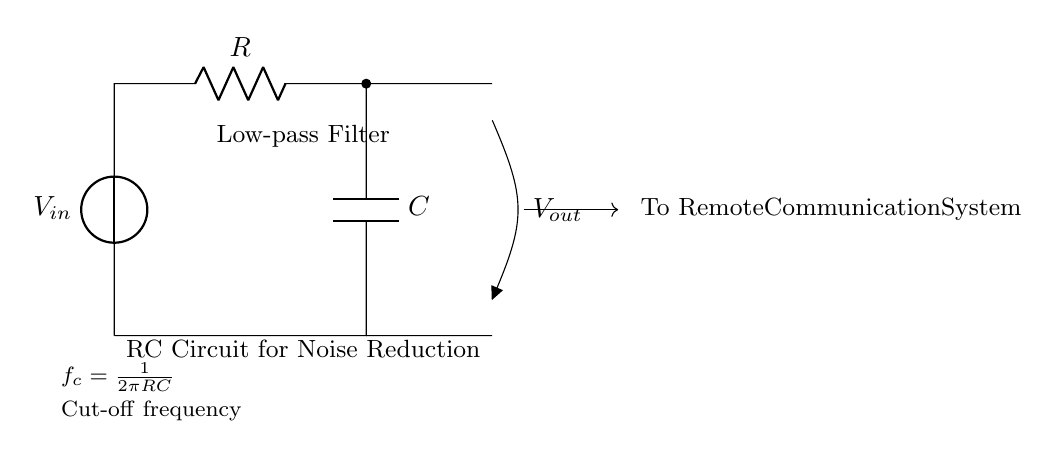What is the input voltage source labeled as? The input voltage source is labeled as V_in, meaning it is the voltage supplied to the circuit.
Answer: V_in What component is used for filtering in this circuit? The filtering component is the capacitor labeled as C, which works alongside the resistor to create the low-pass filter effect.
Answer: C What is the cut-off frequency formula shown in the diagram? The cut-off frequency formula is given as f_c = 1/(2πRC), indicating the frequency at which the output voltage drops significantly compared to the input.
Answer: f_c = 1/(2πRC) What output voltage is indicated in the circuit? The output voltage is labeled as V_out, which indicates the filtered voltage that is sent out from the circuit.
Answer: V_out What effect does this circuit aim to achieve in remote communication systems? The main goal of the circuit is noise reduction, allowing for clearer communication by filtering out high-frequency noise signals.
Answer: Noise reduction How does the resistor and capacitor in the circuit work together? The resistor R and the capacitor C form a voltage divider that allows low-frequency signals to pass while attenuating higher frequencies, effectively creating a low-pass filter.
Answer: As a low-pass filter What is the significance of the direction indicated for V_out? The direction indicated for V_out as an open output means that the filtered signal is sent to the next stage of a remote communication system, often requiring a connection to an input or processing unit.
Answer: To Remote Communication System 